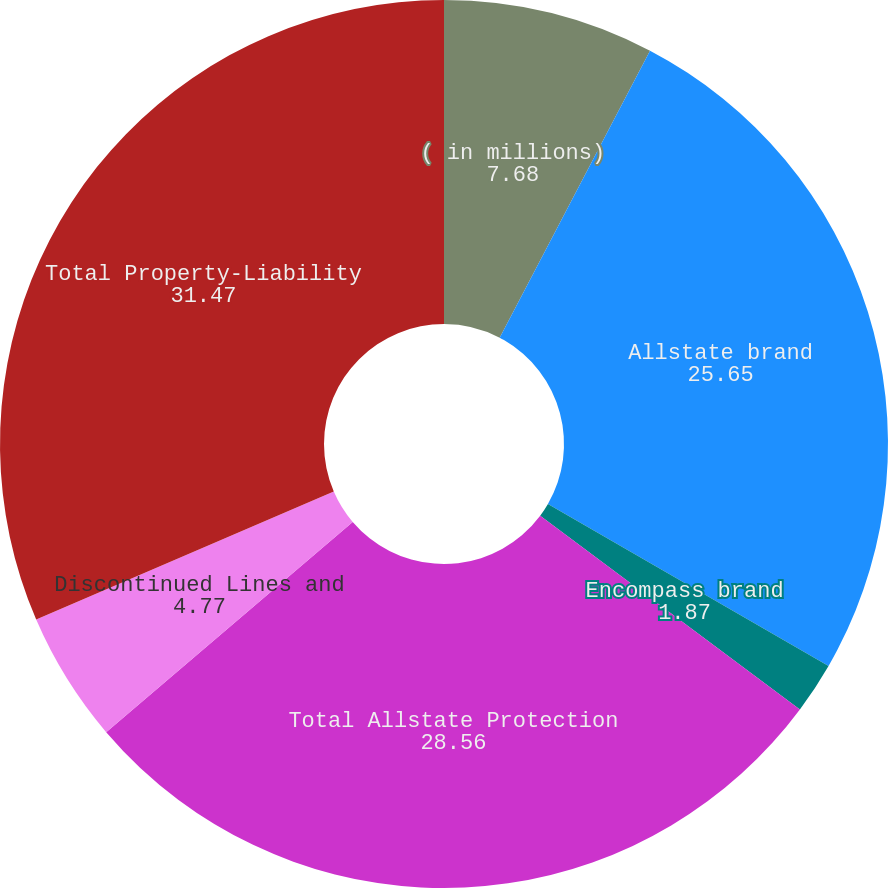Convert chart. <chart><loc_0><loc_0><loc_500><loc_500><pie_chart><fcel>( in millions)<fcel>Allstate brand<fcel>Encompass brand<fcel>Total Allstate Protection<fcel>Discontinued Lines and<fcel>Total Property-Liability<nl><fcel>7.68%<fcel>25.65%<fcel>1.87%<fcel>28.56%<fcel>4.77%<fcel>31.47%<nl></chart> 